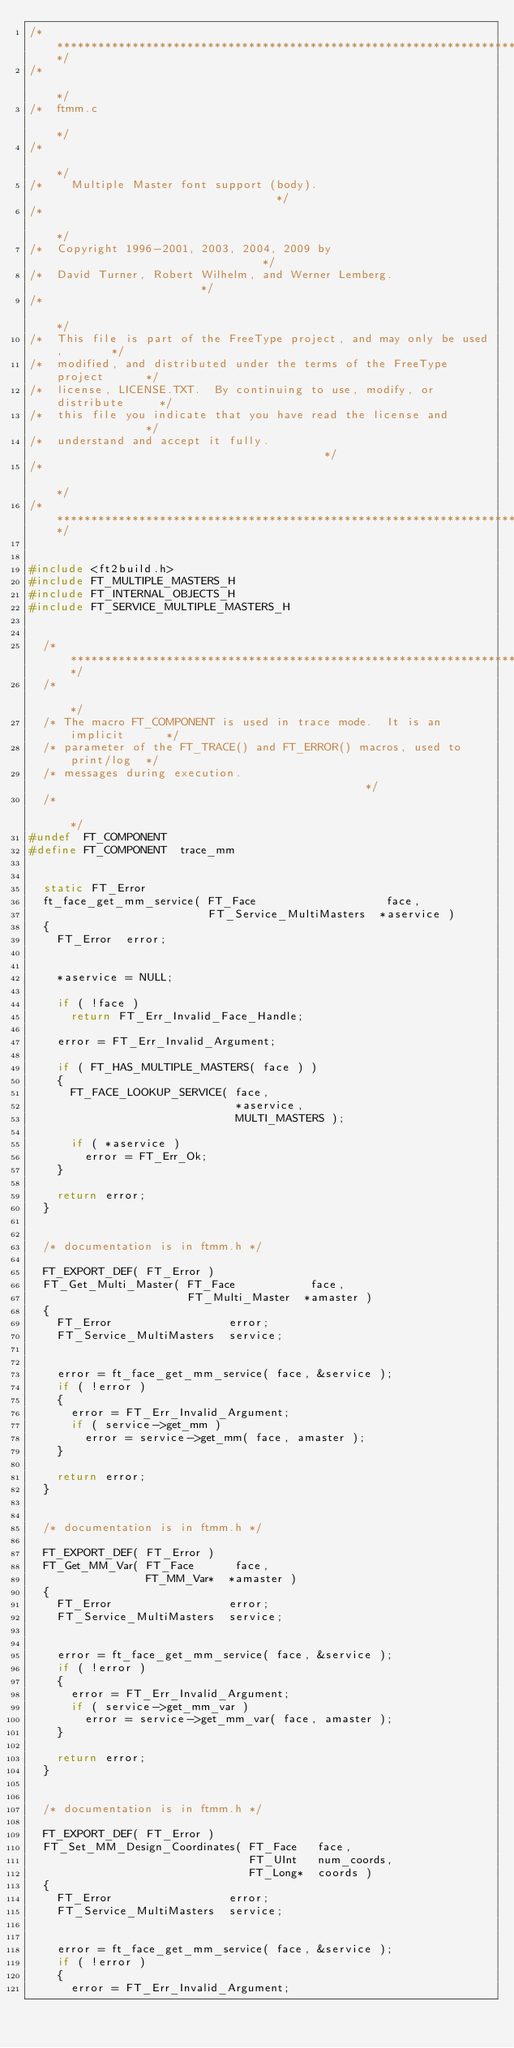<code> <loc_0><loc_0><loc_500><loc_500><_C_>/***************************************************************************/
/*                                                                         */
/*  ftmm.c                                                                 */
/*                                                                         */
/*    Multiple Master font support (body).                                 */
/*                                                                         */
/*  Copyright 1996-2001, 2003, 2004, 2009 by                               */
/*  David Turner, Robert Wilhelm, and Werner Lemberg.                      */
/*                                                                         */
/*  This file is part of the FreeType project, and may only be used,       */
/*  modified, and distributed under the terms of the FreeType project      */
/*  license, LICENSE.TXT.  By continuing to use, modify, or distribute     */
/*  this file you indicate that you have read the license and              */
/*  understand and accept it fully.                                        */
/*                                                                         */
/***************************************************************************/


#include <ft2build.h>
#include FT_MULTIPLE_MASTERS_H
#include FT_INTERNAL_OBJECTS_H
#include FT_SERVICE_MULTIPLE_MASTERS_H


  /*************************************************************************/
  /*                                                                       */
  /* The macro FT_COMPONENT is used in trace mode.  It is an implicit      */
  /* parameter of the FT_TRACE() and FT_ERROR() macros, used to print/log  */
  /* messages during execution.                                            */
  /*                                                                       */
#undef  FT_COMPONENT
#define FT_COMPONENT  trace_mm


  static FT_Error
  ft_face_get_mm_service( FT_Face                   face,
                          FT_Service_MultiMasters  *aservice )
  {
    FT_Error  error;


    *aservice = NULL;

    if ( !face )
      return FT_Err_Invalid_Face_Handle;

    error = FT_Err_Invalid_Argument;

    if ( FT_HAS_MULTIPLE_MASTERS( face ) )
    {
      FT_FACE_LOOKUP_SERVICE( face,
                              *aservice,
                              MULTI_MASTERS );

      if ( *aservice )
        error = FT_Err_Ok;
    }

    return error;
  }


  /* documentation is in ftmm.h */

  FT_EXPORT_DEF( FT_Error )
  FT_Get_Multi_Master( FT_Face           face,
                       FT_Multi_Master  *amaster )
  {
    FT_Error                 error;
    FT_Service_MultiMasters  service;


    error = ft_face_get_mm_service( face, &service );
    if ( !error )
    {
      error = FT_Err_Invalid_Argument;
      if ( service->get_mm )
        error = service->get_mm( face, amaster );
    }

    return error;
  }


  /* documentation is in ftmm.h */

  FT_EXPORT_DEF( FT_Error )
  FT_Get_MM_Var( FT_Face      face,
                 FT_MM_Var*  *amaster )
  {
    FT_Error                 error;
    FT_Service_MultiMasters  service;


    error = ft_face_get_mm_service( face, &service );
    if ( !error )
    {
      error = FT_Err_Invalid_Argument;
      if ( service->get_mm_var )
        error = service->get_mm_var( face, amaster );
    }

    return error;
  }


  /* documentation is in ftmm.h */

  FT_EXPORT_DEF( FT_Error )
  FT_Set_MM_Design_Coordinates( FT_Face   face,
                                FT_UInt   num_coords,
                                FT_Long*  coords )
  {
    FT_Error                 error;
    FT_Service_MultiMasters  service;


    error = ft_face_get_mm_service( face, &service );
    if ( !error )
    {
      error = FT_Err_Invalid_Argument;</code> 